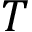<formula> <loc_0><loc_0><loc_500><loc_500>T</formula> 